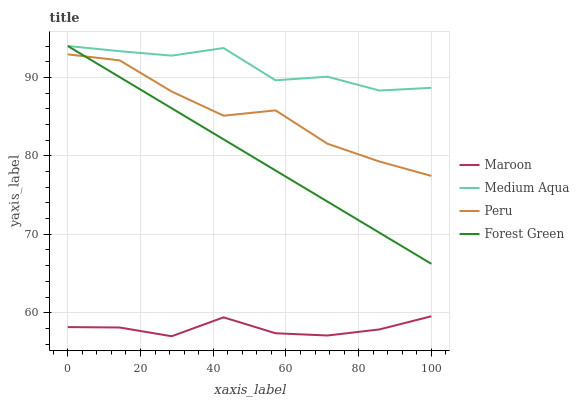Does Maroon have the minimum area under the curve?
Answer yes or no. Yes. Does Medium Aqua have the maximum area under the curve?
Answer yes or no. Yes. Does Peru have the minimum area under the curve?
Answer yes or no. No. Does Peru have the maximum area under the curve?
Answer yes or no. No. Is Forest Green the smoothest?
Answer yes or no. Yes. Is Medium Aqua the roughest?
Answer yes or no. Yes. Is Peru the smoothest?
Answer yes or no. No. Is Peru the roughest?
Answer yes or no. No. Does Maroon have the lowest value?
Answer yes or no. Yes. Does Peru have the lowest value?
Answer yes or no. No. Does Medium Aqua have the highest value?
Answer yes or no. Yes. Does Peru have the highest value?
Answer yes or no. No. Is Peru less than Medium Aqua?
Answer yes or no. Yes. Is Medium Aqua greater than Peru?
Answer yes or no. Yes. Does Medium Aqua intersect Forest Green?
Answer yes or no. Yes. Is Medium Aqua less than Forest Green?
Answer yes or no. No. Is Medium Aqua greater than Forest Green?
Answer yes or no. No. Does Peru intersect Medium Aqua?
Answer yes or no. No. 